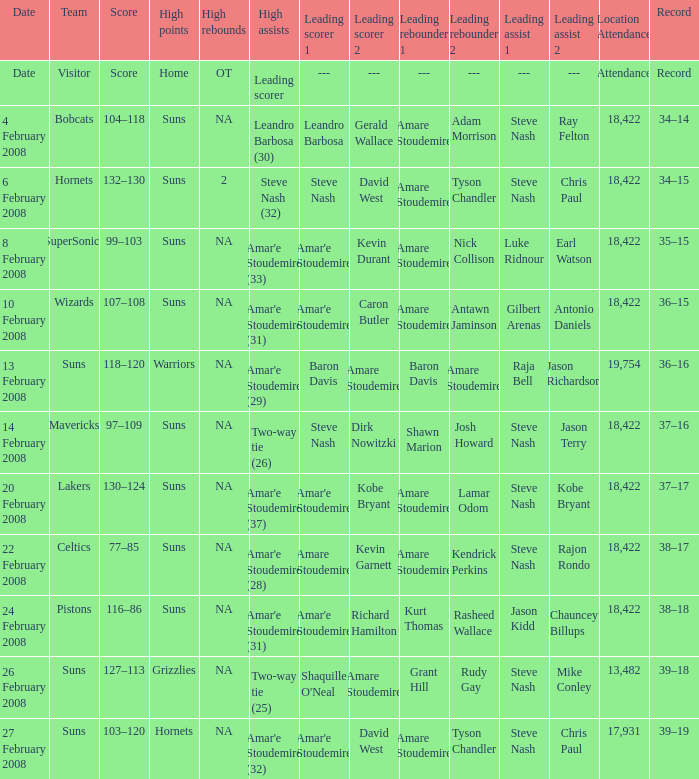How many high assists did the Lakers have? Amar'e Stoudemire (37). 